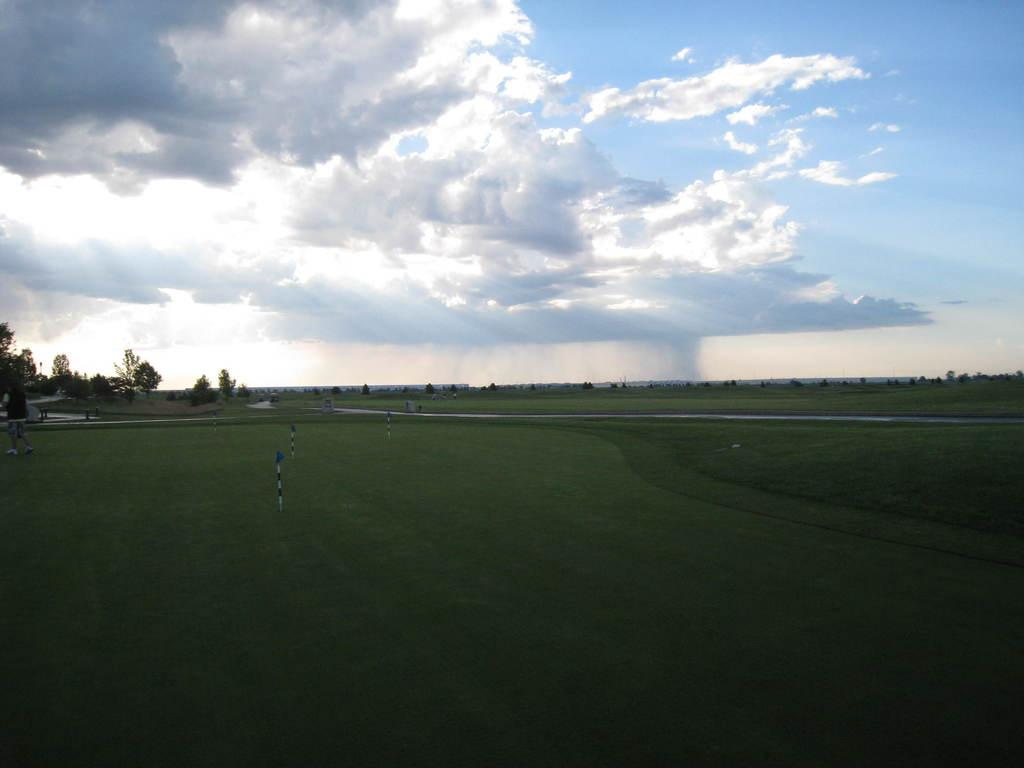What can be seen on the ground in the image? There is a group of poles on the ground in the image. What else is present in the image besides the poles? There is a group of trees in the image. What is visible in the background of the image? The sky is visible in the background of the image, and it appears to be cloudy. Can you hear the crowd laughing in the image? There is no crowd or laughter present in the image; it only features a group of poles, a group of trees, and a cloudy sky. 